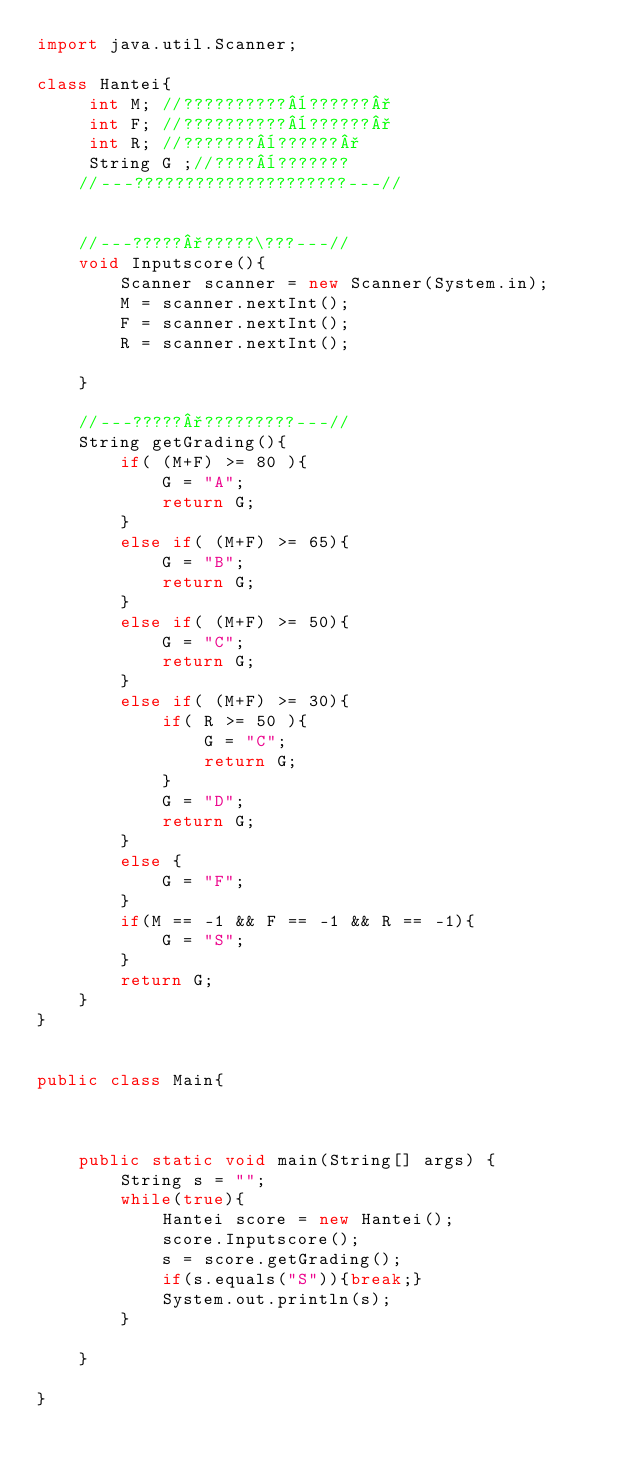Convert code to text. <code><loc_0><loc_0><loc_500><loc_500><_Java_>import java.util.Scanner;

class Hantei{
	 int M;	//??????????¨??????°
	 int F;	//??????????¨??????°
	 int R;	//???????¨??????°
	 String G ;//????¨???????
	//---?????????????????????---//

	
	//---?????°?????\???---//
	void Inputscore(){
		Scanner scanner = new Scanner(System.in);
		M = scanner.nextInt();
		F = scanner.nextInt();
		R = scanner.nextInt();
		
	}
	
	//---?????°?????????---//
	String getGrading(){
		if( (M+F) >= 80 ){
			G = "A";
			return G;
		}
		else if( (M+F) >= 65){
			G = "B";
			return G;
		}
		else if( (M+F) >= 50){
			G = "C";
			return G;
		}
		else if( (M+F) >= 30){
			if( R >= 50 ){
				G = "C";
				return G;
			}
			G = "D";
			return G;
		}
		else {
			G = "F";
		}
		if(M == -1 && F == -1 && R == -1){
			G = "S";
		}
		return G;	
	}	
}


public class Main{
 
	
	
	public static void main(String[] args) {
		String s = "";
		while(true){
			Hantei score = new Hantei();
			score.Inputscore();
			s = score.getGrading();
			if(s.equals("S")){break;}
			System.out.println(s);
		}

	}

}</code> 